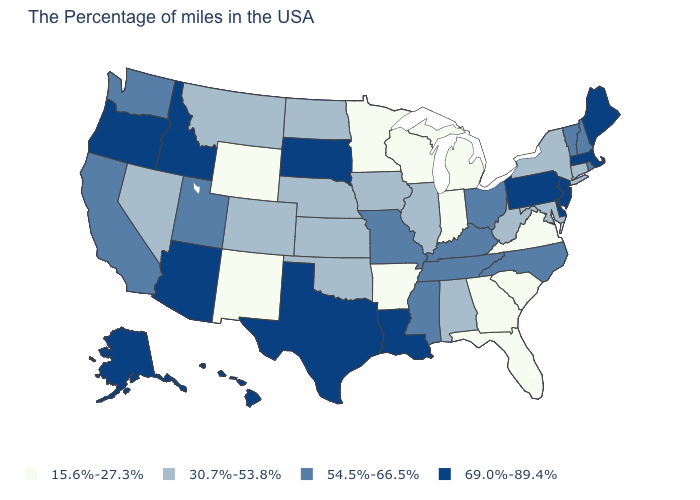Name the states that have a value in the range 15.6%-27.3%?
Quick response, please. Virginia, South Carolina, Florida, Georgia, Michigan, Indiana, Wisconsin, Arkansas, Minnesota, Wyoming, New Mexico. Which states hav the highest value in the West?
Be succinct. Arizona, Idaho, Oregon, Alaska, Hawaii. What is the value of Maryland?
Answer briefly. 30.7%-53.8%. What is the value of California?
Quick response, please. 54.5%-66.5%. Name the states that have a value in the range 30.7%-53.8%?
Give a very brief answer. Connecticut, New York, Maryland, West Virginia, Alabama, Illinois, Iowa, Kansas, Nebraska, Oklahoma, North Dakota, Colorado, Montana, Nevada. Among the states that border Maryland , does West Virginia have the highest value?
Concise answer only. No. Name the states that have a value in the range 15.6%-27.3%?
Be succinct. Virginia, South Carolina, Florida, Georgia, Michigan, Indiana, Wisconsin, Arkansas, Minnesota, Wyoming, New Mexico. What is the value of Virginia?
Answer briefly. 15.6%-27.3%. What is the value of Arizona?
Write a very short answer. 69.0%-89.4%. Does Georgia have the lowest value in the USA?
Concise answer only. Yes. Among the states that border Georgia , does North Carolina have the highest value?
Quick response, please. Yes. Which states hav the highest value in the Northeast?
Give a very brief answer. Maine, Massachusetts, New Jersey, Pennsylvania. Name the states that have a value in the range 69.0%-89.4%?
Answer briefly. Maine, Massachusetts, New Jersey, Delaware, Pennsylvania, Louisiana, Texas, South Dakota, Arizona, Idaho, Oregon, Alaska, Hawaii. Is the legend a continuous bar?
Give a very brief answer. No. Name the states that have a value in the range 54.5%-66.5%?
Give a very brief answer. Rhode Island, New Hampshire, Vermont, North Carolina, Ohio, Kentucky, Tennessee, Mississippi, Missouri, Utah, California, Washington. 